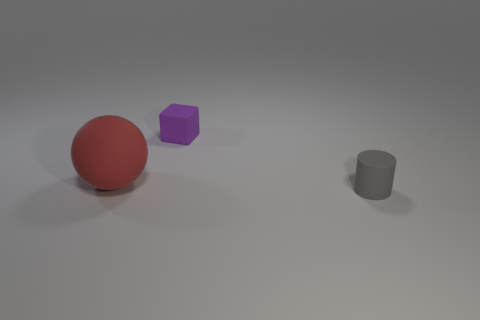What is the shape of the thing to the left of the object that is behind the big sphere?
Offer a very short reply. Sphere. Is there any other thing that is the same size as the matte sphere?
Offer a very short reply. No. The small thing that is in front of the big thing is what color?
Your answer should be compact. Gray. What material is the thing that is on the right side of the small matte object that is behind the small object that is in front of the red rubber ball?
Your answer should be very brief. Rubber. There is a red thing that is left of the small cube behind the ball; what size is it?
Offer a very short reply. Large. Does the matte block have the same size as the gray matte thing?
Make the answer very short. Yes. There is a big thing that is made of the same material as the small purple block; what color is it?
Provide a succinct answer. Red. Is the gray thing made of the same material as the object that is on the left side of the cube?
Your answer should be very brief. Yes. What number of cylinders are made of the same material as the small purple thing?
Your answer should be very brief. 1. What is the shape of the tiny rubber object that is on the right side of the tiny purple block?
Keep it short and to the point. Cylinder. 